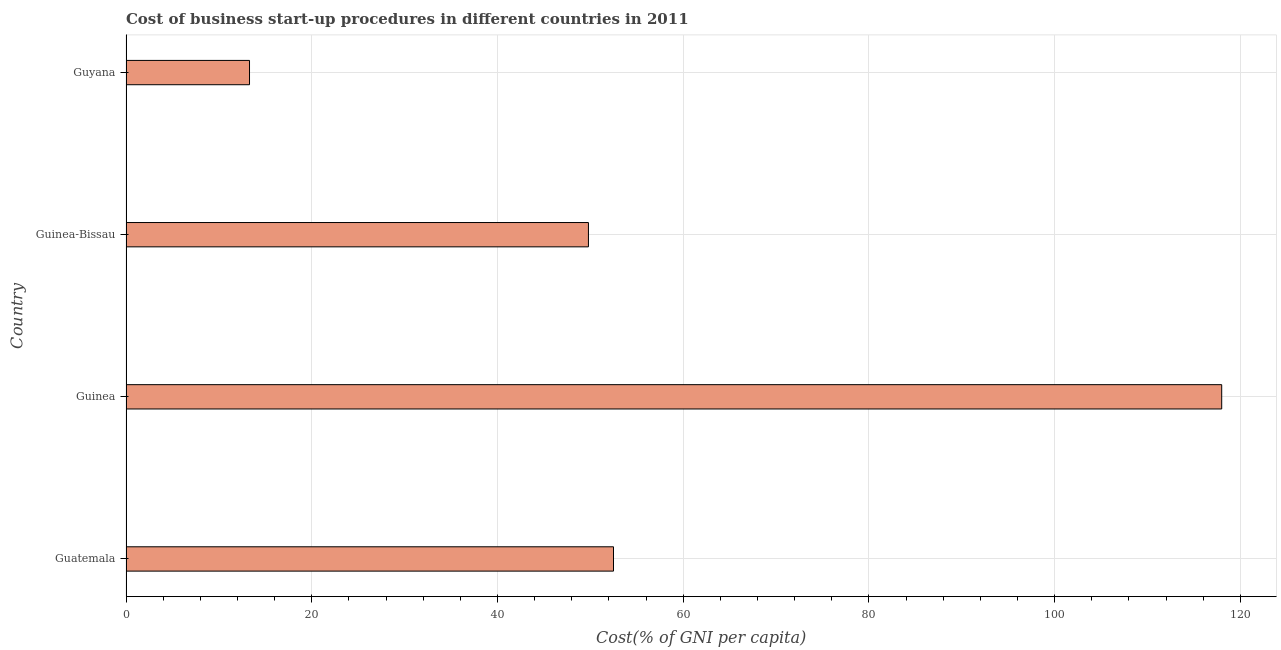Does the graph contain grids?
Give a very brief answer. Yes. What is the title of the graph?
Give a very brief answer. Cost of business start-up procedures in different countries in 2011. What is the label or title of the X-axis?
Your answer should be compact. Cost(% of GNI per capita). What is the cost of business startup procedures in Guinea-Bissau?
Keep it short and to the point. 49.8. Across all countries, what is the maximum cost of business startup procedures?
Your answer should be compact. 118. Across all countries, what is the minimum cost of business startup procedures?
Offer a terse response. 13.3. In which country was the cost of business startup procedures maximum?
Provide a short and direct response. Guinea. In which country was the cost of business startup procedures minimum?
Make the answer very short. Guyana. What is the sum of the cost of business startup procedures?
Offer a very short reply. 233.6. What is the difference between the cost of business startup procedures in Guatemala and Guinea?
Provide a short and direct response. -65.5. What is the average cost of business startup procedures per country?
Offer a very short reply. 58.4. What is the median cost of business startup procedures?
Offer a terse response. 51.15. In how many countries, is the cost of business startup procedures greater than 68 %?
Provide a succinct answer. 1. What is the ratio of the cost of business startup procedures in Guinea to that in Guyana?
Your answer should be very brief. 8.87. Is the cost of business startup procedures in Guinea less than that in Guyana?
Offer a very short reply. No. What is the difference between the highest and the second highest cost of business startup procedures?
Provide a short and direct response. 65.5. Is the sum of the cost of business startup procedures in Guatemala and Guyana greater than the maximum cost of business startup procedures across all countries?
Provide a short and direct response. No. What is the difference between the highest and the lowest cost of business startup procedures?
Keep it short and to the point. 104.7. How many bars are there?
Make the answer very short. 4. Are all the bars in the graph horizontal?
Make the answer very short. Yes. Are the values on the major ticks of X-axis written in scientific E-notation?
Make the answer very short. No. What is the Cost(% of GNI per capita) in Guatemala?
Your answer should be very brief. 52.5. What is the Cost(% of GNI per capita) of Guinea?
Offer a very short reply. 118. What is the Cost(% of GNI per capita) in Guinea-Bissau?
Make the answer very short. 49.8. What is the difference between the Cost(% of GNI per capita) in Guatemala and Guinea?
Your answer should be very brief. -65.5. What is the difference between the Cost(% of GNI per capita) in Guatemala and Guinea-Bissau?
Your answer should be compact. 2.7. What is the difference between the Cost(% of GNI per capita) in Guatemala and Guyana?
Your response must be concise. 39.2. What is the difference between the Cost(% of GNI per capita) in Guinea and Guinea-Bissau?
Your answer should be compact. 68.2. What is the difference between the Cost(% of GNI per capita) in Guinea and Guyana?
Provide a succinct answer. 104.7. What is the difference between the Cost(% of GNI per capita) in Guinea-Bissau and Guyana?
Your answer should be very brief. 36.5. What is the ratio of the Cost(% of GNI per capita) in Guatemala to that in Guinea?
Offer a terse response. 0.45. What is the ratio of the Cost(% of GNI per capita) in Guatemala to that in Guinea-Bissau?
Make the answer very short. 1.05. What is the ratio of the Cost(% of GNI per capita) in Guatemala to that in Guyana?
Ensure brevity in your answer.  3.95. What is the ratio of the Cost(% of GNI per capita) in Guinea to that in Guinea-Bissau?
Keep it short and to the point. 2.37. What is the ratio of the Cost(% of GNI per capita) in Guinea to that in Guyana?
Give a very brief answer. 8.87. What is the ratio of the Cost(% of GNI per capita) in Guinea-Bissau to that in Guyana?
Your response must be concise. 3.74. 